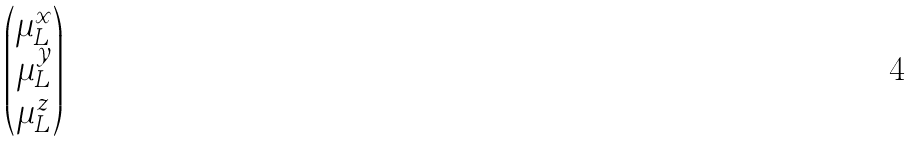Convert formula to latex. <formula><loc_0><loc_0><loc_500><loc_500>\begin{pmatrix} \mu ^ { x } _ { L } \\ \mu ^ { y } _ { L } \\ \mu ^ { z } _ { L } \end{pmatrix}</formula> 